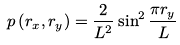<formula> <loc_0><loc_0><loc_500><loc_500>p \left ( r _ { x } , r _ { y } \right ) = \frac { 2 } { L ^ { 2 } } \sin ^ { 2 } \frac { \pi r _ { y } } { L }</formula> 